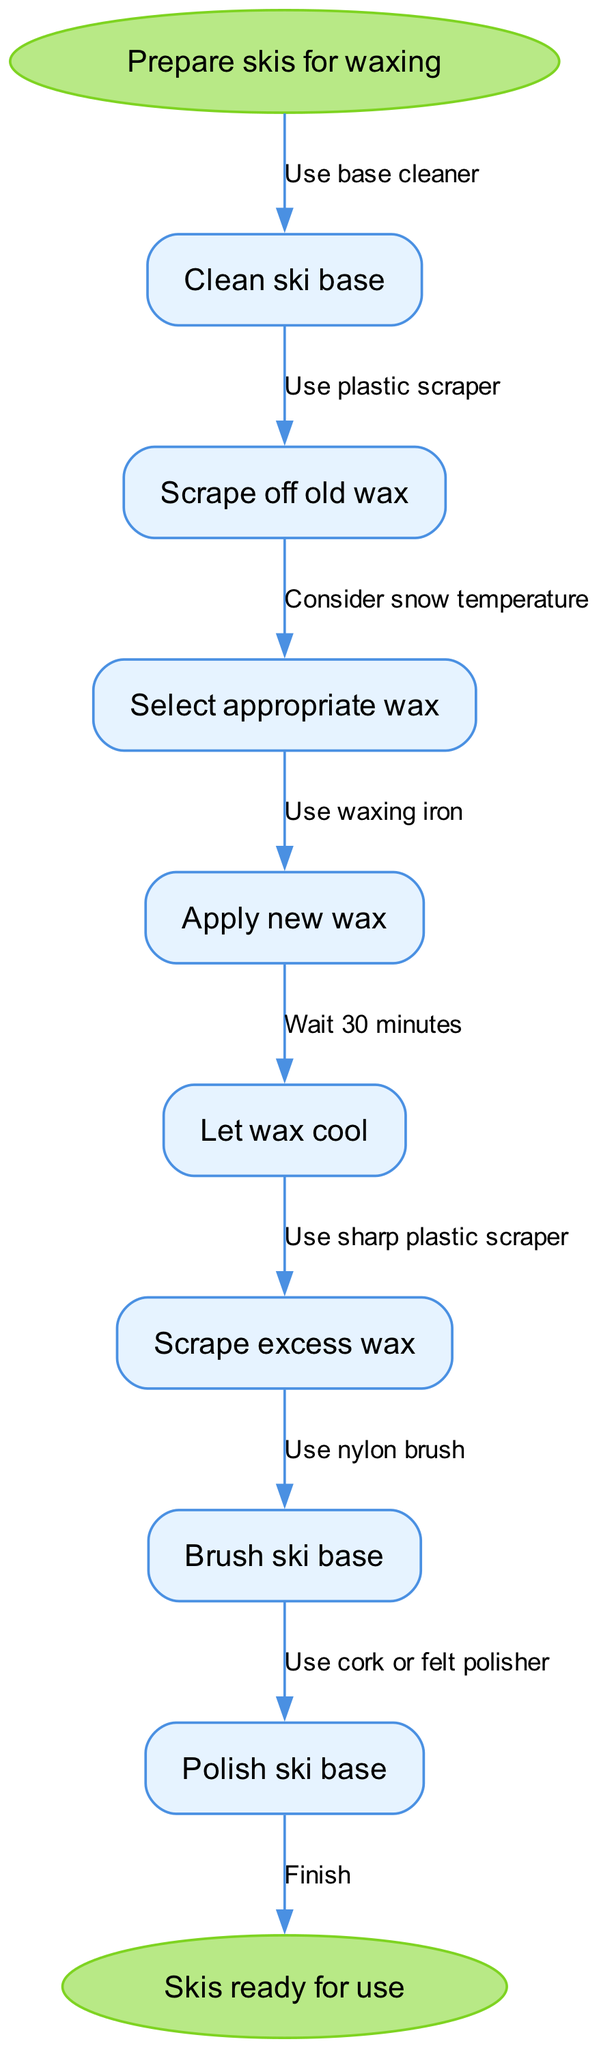What is the first step in the waxing process? The diagram starts with the node labeled "Prepare skis for waxing". The next node directly connected to it specifies "Clean ski base", which is the first actionable step in the process.
Answer: Clean ski base How many steps are there in the process? The diagram contains a total of eight nodes, including the start and end nodes. The steps in between also count as nodes, and they specifically detail the waxing process.
Answer: Eight What is used for scraping off old wax? In the diagram, the edge from the "Scrape off old wax" node specifies that a "Use plastic scraper" is to be employed, clearly indicating the tool required for this step.
Answer: Plastic scraper What should you consider when selecting appropriate wax? The edge connected to the node "Select appropriate wax" indicates that one should "Consider snow temperature". This shows the specific factor influencing wax selection.
Answer: Snow temperature How long should you wait for the wax to cool? The edge direct from the "Let wax cool" node indicates a clear timeframe; it states to "Wait 30 minutes". This explains the cooling time required after applying wax.
Answer: 30 minutes What is the last step to complete before skis are ready for use? The final process before reaching the "Skis ready for use" node is linked to the "Polish ski base" node, thus indicating that polishing is the concluding action required.
Answer: Polish ski base Which tool is used for brushing the ski base? From the node "Brush ski base", the edge states that a "Use nylon brush" is specified. This indicates the exact tool necessary for the brushing step in the process.
Answer: Nylon brush What is the relationship between scraping excess wax and polishing? The diagram shows that after "Scrape excess wax", the next step is "Brush ski base", followed closely by "Polish ski base". Thus, polishing is done after scraping excess wax and brushing.
Answer: Polishing is after scraping excess wax 